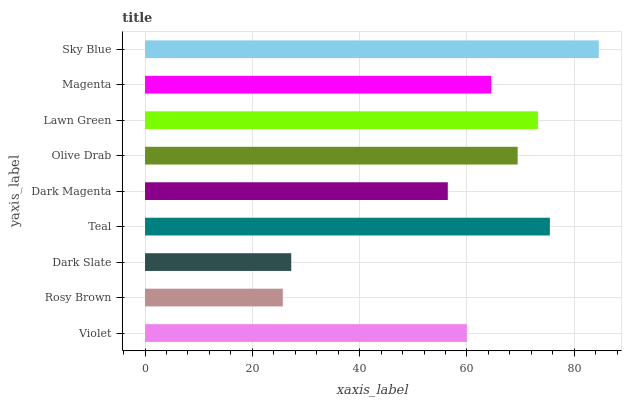Is Rosy Brown the minimum?
Answer yes or no. Yes. Is Sky Blue the maximum?
Answer yes or no. Yes. Is Dark Slate the minimum?
Answer yes or no. No. Is Dark Slate the maximum?
Answer yes or no. No. Is Dark Slate greater than Rosy Brown?
Answer yes or no. Yes. Is Rosy Brown less than Dark Slate?
Answer yes or no. Yes. Is Rosy Brown greater than Dark Slate?
Answer yes or no. No. Is Dark Slate less than Rosy Brown?
Answer yes or no. No. Is Magenta the high median?
Answer yes or no. Yes. Is Magenta the low median?
Answer yes or no. Yes. Is Lawn Green the high median?
Answer yes or no. No. Is Dark Magenta the low median?
Answer yes or no. No. 